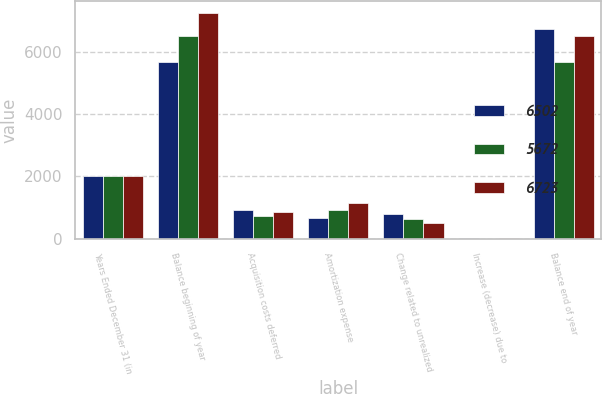<chart> <loc_0><loc_0><loc_500><loc_500><stacked_bar_chart><ecel><fcel>Years Ended December 31 (in<fcel>Balance beginning of year<fcel>Acquisition costs deferred<fcel>Amortization expense<fcel>Change related to unrealized<fcel>Increase (decrease) due to<fcel>Balance end of year<nl><fcel>6502<fcel>2013<fcel>5672<fcel>930<fcel>658<fcel>784<fcel>5<fcel>6723<nl><fcel>5672<fcel>2012<fcel>6502<fcel>724<fcel>931<fcel>621<fcel>2<fcel>5672<nl><fcel>6723<fcel>2011<fcel>7258<fcel>869<fcel>1142<fcel>486<fcel>3<fcel>6502<nl></chart> 